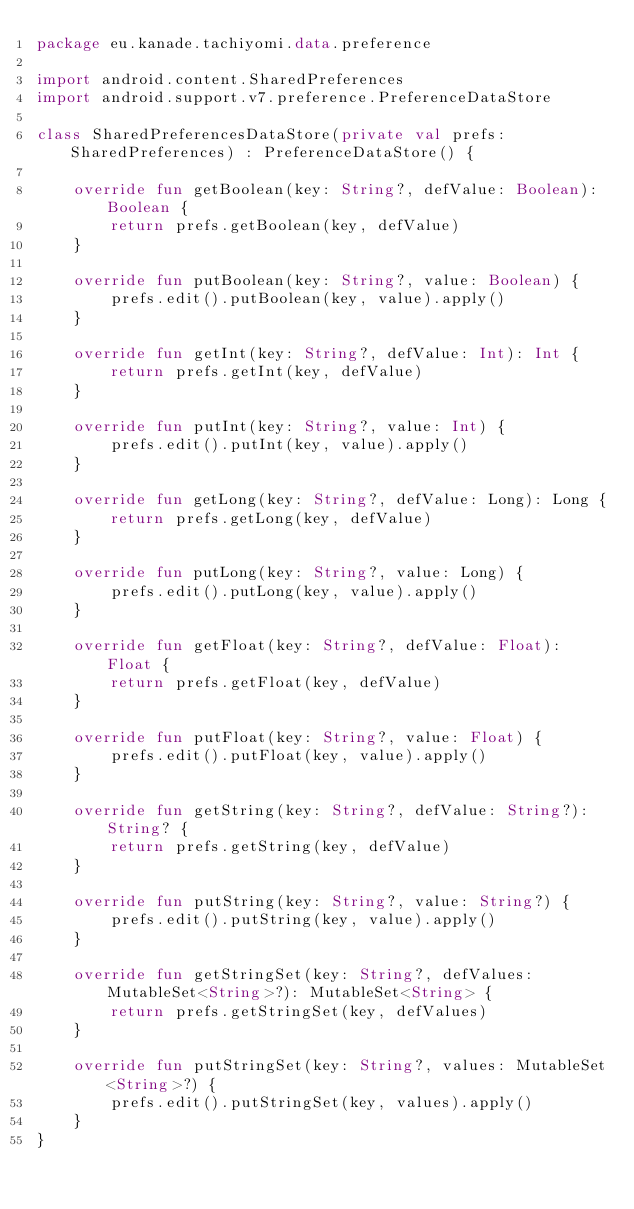<code> <loc_0><loc_0><loc_500><loc_500><_Kotlin_>package eu.kanade.tachiyomi.data.preference

import android.content.SharedPreferences
import android.support.v7.preference.PreferenceDataStore

class SharedPreferencesDataStore(private val prefs: SharedPreferences) : PreferenceDataStore() {

    override fun getBoolean(key: String?, defValue: Boolean): Boolean {
        return prefs.getBoolean(key, defValue)
    }

    override fun putBoolean(key: String?, value: Boolean) {
        prefs.edit().putBoolean(key, value).apply()
    }

    override fun getInt(key: String?, defValue: Int): Int {
        return prefs.getInt(key, defValue)
    }

    override fun putInt(key: String?, value: Int) {
        prefs.edit().putInt(key, value).apply()
    }

    override fun getLong(key: String?, defValue: Long): Long {
        return prefs.getLong(key, defValue)
    }

    override fun putLong(key: String?, value: Long) {
        prefs.edit().putLong(key, value).apply()
    }

    override fun getFloat(key: String?, defValue: Float): Float {
        return prefs.getFloat(key, defValue)
    }

    override fun putFloat(key: String?, value: Float) {
        prefs.edit().putFloat(key, value).apply()
    }

    override fun getString(key: String?, defValue: String?): String? {
        return prefs.getString(key, defValue)
    }

    override fun putString(key: String?, value: String?) {
        prefs.edit().putString(key, value).apply()
    }

    override fun getStringSet(key: String?, defValues: MutableSet<String>?): MutableSet<String> {
        return prefs.getStringSet(key, defValues)
    }

    override fun putStringSet(key: String?, values: MutableSet<String>?) {
        prefs.edit().putStringSet(key, values).apply()
    }
}</code> 